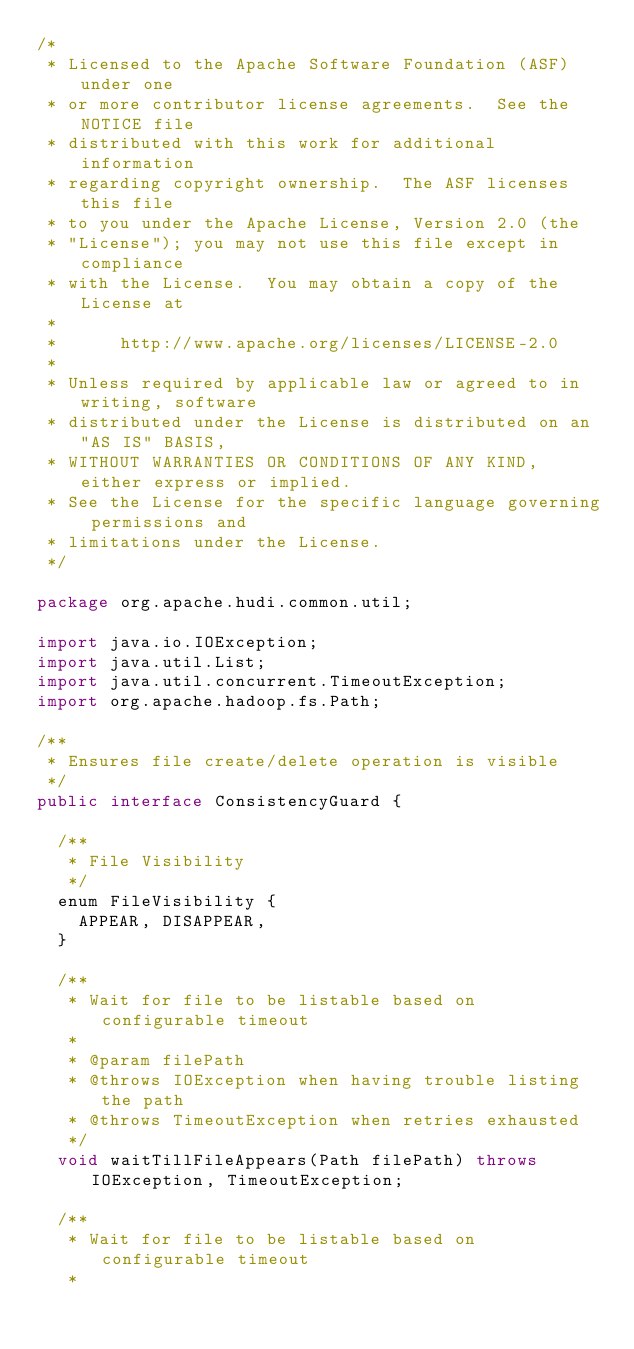<code> <loc_0><loc_0><loc_500><loc_500><_Java_>/*
 * Licensed to the Apache Software Foundation (ASF) under one
 * or more contributor license agreements.  See the NOTICE file
 * distributed with this work for additional information
 * regarding copyright ownership.  The ASF licenses this file
 * to you under the Apache License, Version 2.0 (the
 * "License"); you may not use this file except in compliance
 * with the License.  You may obtain a copy of the License at
 *
 *      http://www.apache.org/licenses/LICENSE-2.0
 *
 * Unless required by applicable law or agreed to in writing, software
 * distributed under the License is distributed on an "AS IS" BASIS,
 * WITHOUT WARRANTIES OR CONDITIONS OF ANY KIND, either express or implied.
 * See the License for the specific language governing permissions and
 * limitations under the License.
 */

package org.apache.hudi.common.util;

import java.io.IOException;
import java.util.List;
import java.util.concurrent.TimeoutException;
import org.apache.hadoop.fs.Path;

/**
 * Ensures file create/delete operation is visible
 */
public interface ConsistencyGuard {

  /**
   * File Visibility
   */
  enum FileVisibility {
    APPEAR, DISAPPEAR,
  }

  /**
   * Wait for file to be listable based on configurable timeout
   * 
   * @param filePath
   * @throws IOException when having trouble listing the path
   * @throws TimeoutException when retries exhausted
   */
  void waitTillFileAppears(Path filePath) throws IOException, TimeoutException;

  /**
   * Wait for file to be listable based on configurable timeout
   * </code> 